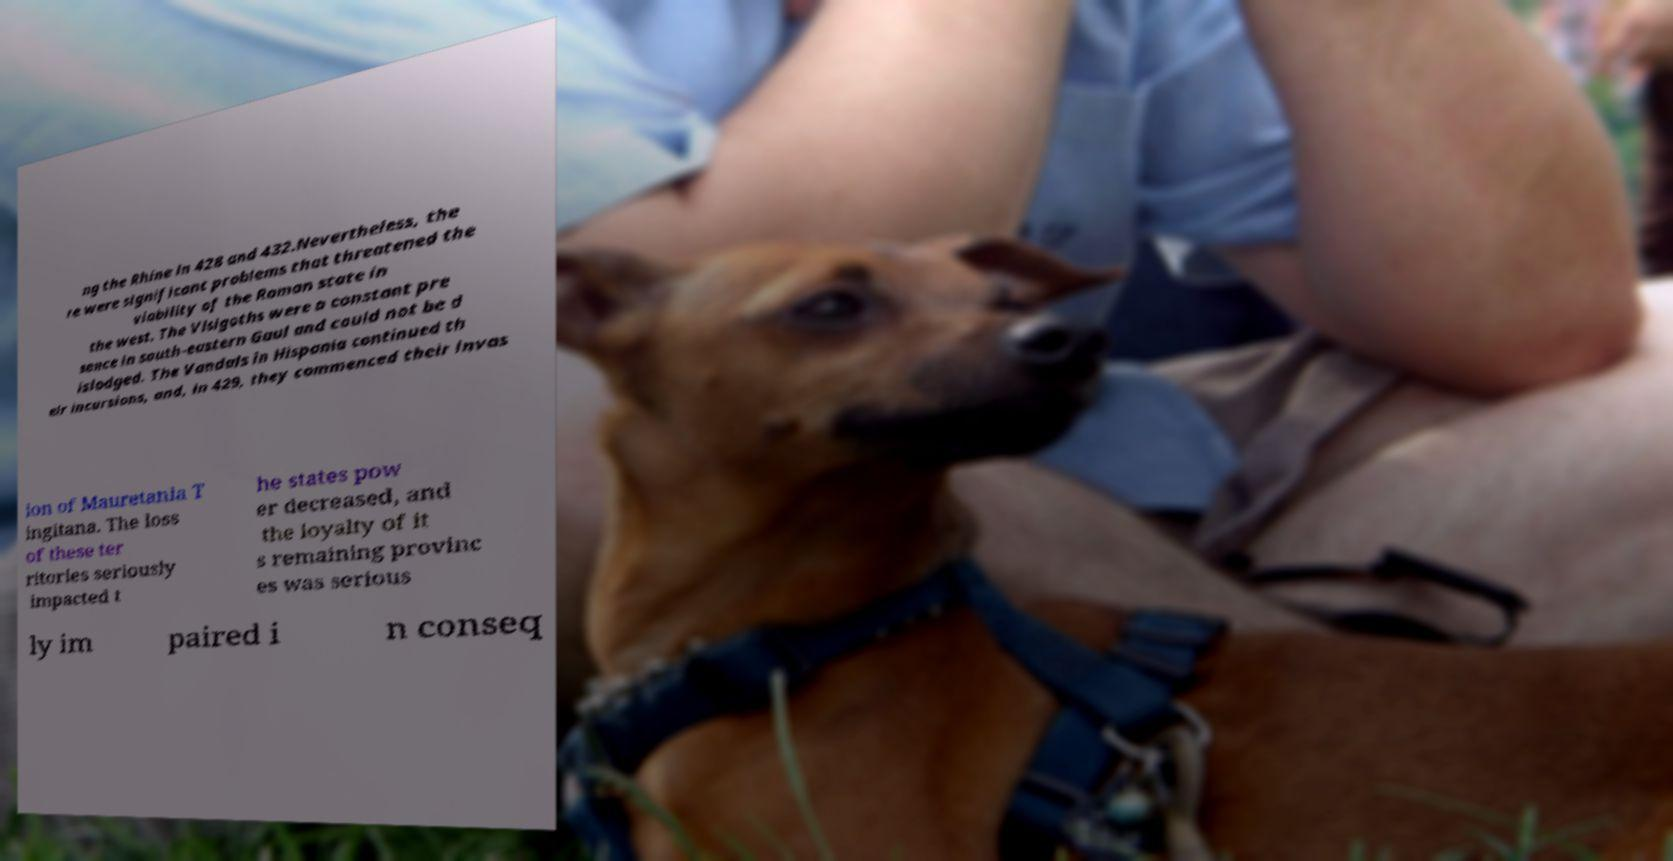Please identify and transcribe the text found in this image. ng the Rhine in 428 and 432.Nevertheless, the re were significant problems that threatened the viability of the Roman state in the west. The Visigoths were a constant pre sence in south-eastern Gaul and could not be d islodged. The Vandals in Hispania continued th eir incursions, and, in 429, they commenced their invas ion of Mauretania T ingitana. The loss of these ter ritories seriously impacted t he states pow er decreased, and the loyalty of it s remaining provinc es was serious ly im paired i n conseq 